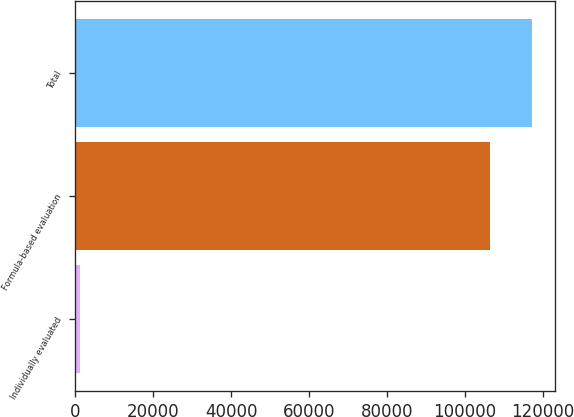Convert chart to OTSL. <chart><loc_0><loc_0><loc_500><loc_500><bar_chart><fcel>Individually evaluated<fcel>Formula-based evaluation<fcel>Total<nl><fcel>1223<fcel>106446<fcel>117091<nl></chart> 